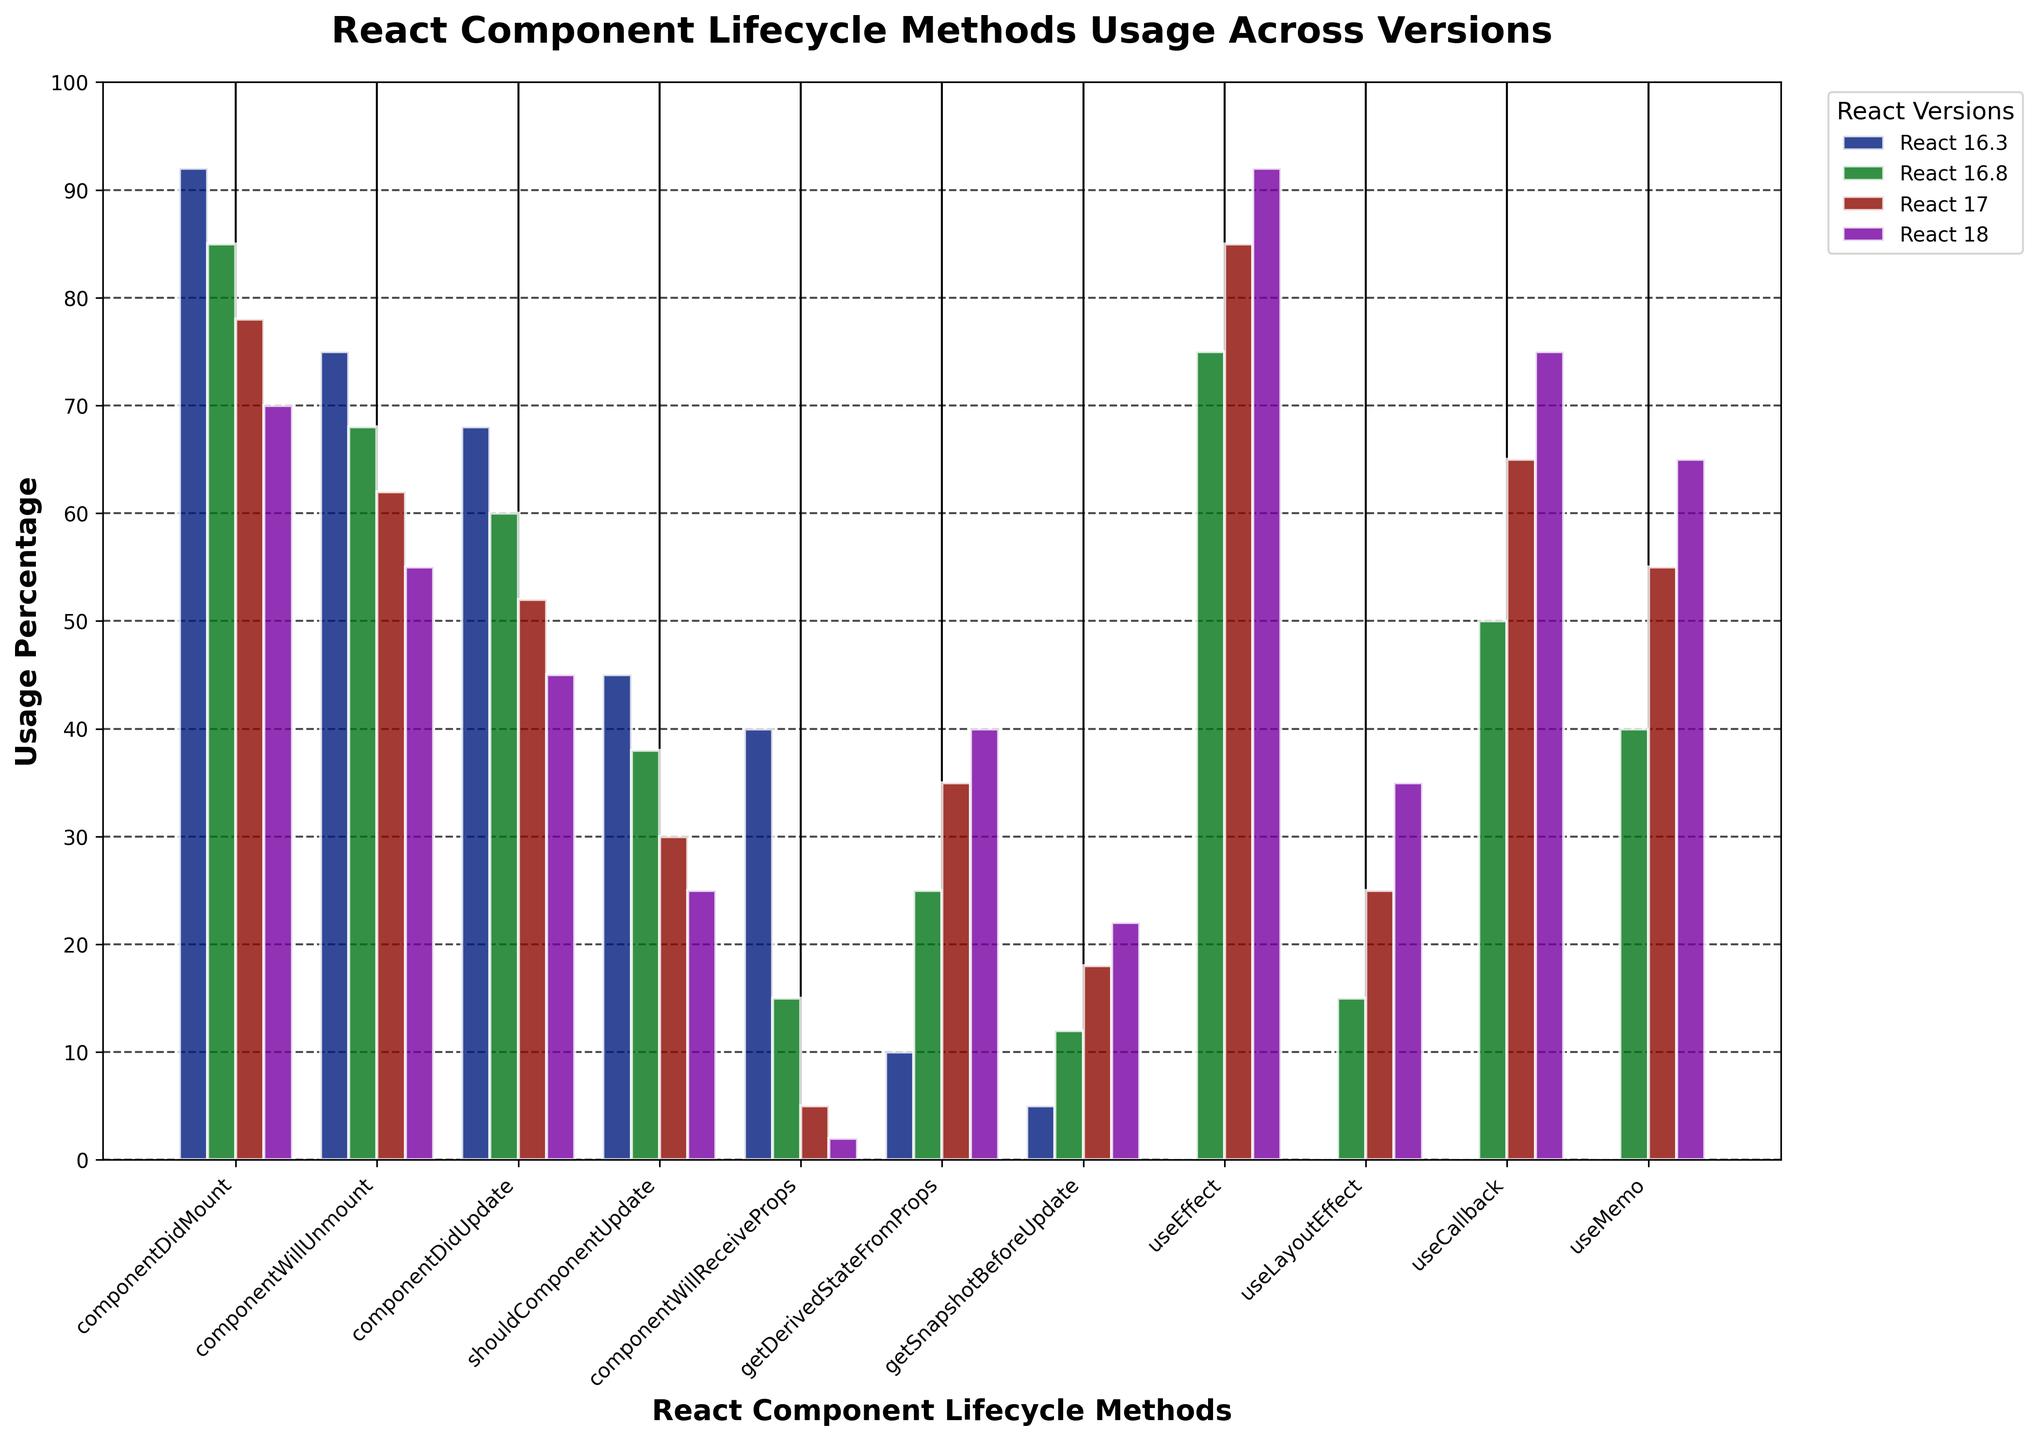Which React lifecycle method saw the highest usage decline from React 16.3 to React 18? To determine this, compare the percentage declines of each method by subtracting the React 18 percentage from the React 16.3 percentage for each method. The largest difference indicates the highest usage decline. For componentWillReceiveProps, it declined from 40% to 2%, a decline of 38%, which is the highest.
Answer: componentWillReceiveProps Which version introduced the usage of hooks like useEffect? Refer to the bars corresponding to useEffect. Notice that from React 16.3 to React 16.8, useEffect jumps from 0% to 75%, indicating it was introduced in React 16.8.
Answer: React 16.8 What's the average usage percentage of componentDidMount across all versions? Sum the usage percentages of componentDidMount across React 16.3, 16.8, 17, and 18, then divide by the number of versions: (92% + 85% + 78% + 70%)/4 = 325% / 4 = 81.25%.
Answer: 81.25% Which method had a higher usage in React 18, getSnapshotBeforeUpdate or useLayoutEffect? Compare the heights of the bars for getSnapshotBeforeUpdate and useLayoutEffect in React 18. getSnapshotBeforeUpdate is at 22% while useLayoutEffect is at 35%.
Answer: useLayoutEffect Was the usage of componentDidMount higher or lower than componentDidUpdate in React 17? Inspect the bars for componentDidMount and componentDidUpdate in React 17. componentDidMount has 78% while componentDidUpdate has 52%, indicating componentDidMount is higher.
Answer: Higher What is the sum of the usage percentages for useCallback and useMemo in React 18? Add the usage percentages for useCallback and useMemo in React 18: 75% + 65% = 140%.
Answer: 140% How many methods had a usage percentage above 60% in React 16.3? Count the methods in the React 16.3 column with percentages above 60%. These are componentDidMount (92%), componentWillUnmount (75%), and componentDidUpdate (68%), totaling 3 methods.
Answer: 3 By how much did the usage of getDerivedStateFromProps increase from React 16.3 to React 18? Subtract the usage percentage of getDerivedStateFromProps in React 16.3 from that in React 18: 40% - 10% = 30%.
Answer: 30% Which updated React lifecycle method consistently declined in usage across all versions? Identify methods that show a decrease in usage percentage from React 16.3 to React 18. componentDidMount, componentWillUnmount, componentDidUpdate, and shouldComponentUpdate all consistently decline.
Answer: componentDidMount, componentWillUnmount, componentDidUpdate, shouldComponentUpdate Which version showed the highest usage of useMemo? Compare the heights of the bars for useMemo across different versions. React 18 has the highest bar at 65%.
Answer: React 18 